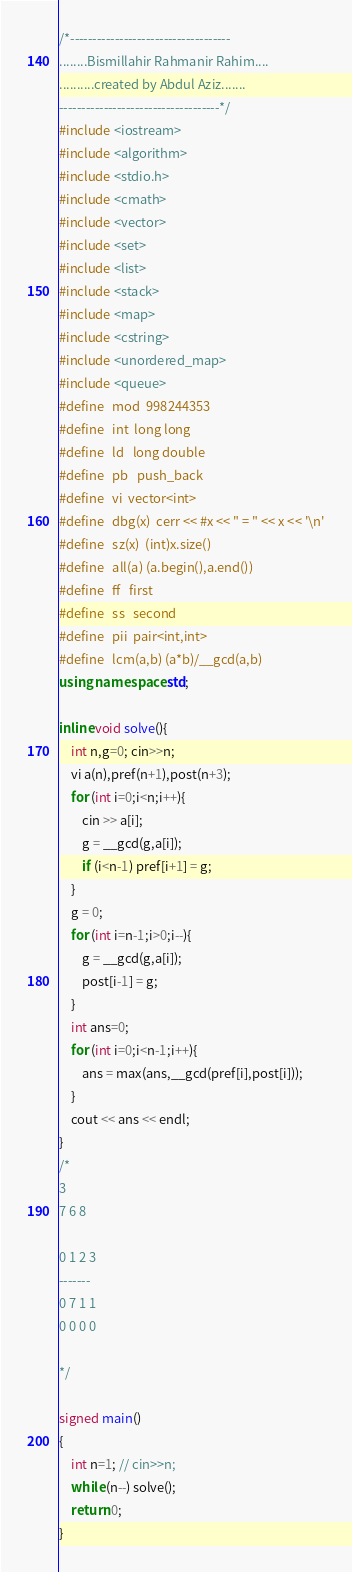<code> <loc_0><loc_0><loc_500><loc_500><_C++_>/*------------------------------------
........Bismillahir Rahmanir Rahim....
..........created by Abdul Aziz.......
------------------------------------*/
#include <iostream>
#include <algorithm>
#include <stdio.h>
#include <cmath>
#include <vector>
#include <set>
#include <list>
#include <stack>
#include <map>
#include <cstring>
#include <unordered_map>
#include <queue>
#define   mod  998244353
#define   int  long long 
#define   ld   long double
#define   pb   push_back
#define   vi  vector<int> 
#define   dbg(x)  cerr << #x << " = " << x << '\n'
#define   sz(x)  (int)x.size()
#define   all(a) (a.begin(),a.end())
#define   ff   first
#define   ss   second
#define   pii  pair<int,int> 
#define   lcm(a,b) (a*b)/__gcd(a,b) 
using namespace std;

inline void solve(){
    int n,g=0; cin>>n; 
    vi a(n),pref(n+1),post(n+3);
    for (int i=0;i<n;i++){
        cin >> a[i]; 
        g = __gcd(g,a[i]);
        if (i<n-1) pref[i+1] = g; 
    }
    g = 0;
    for (int i=n-1;i>0;i--){
        g = __gcd(g,a[i]);
        post[i-1] = g;
    } 
    int ans=0;
    for (int i=0;i<n-1;i++){
        ans = max(ans,__gcd(pref[i],post[i]));
    }
    cout << ans << endl;
}
/*
3
7 6 8

0 1 2 3
-------
0 7 1 1
0 0 0 0

*/

signed main()
{
    int n=1; // cin>>n;
    while (n--) solve();
    return 0;
}
</code> 